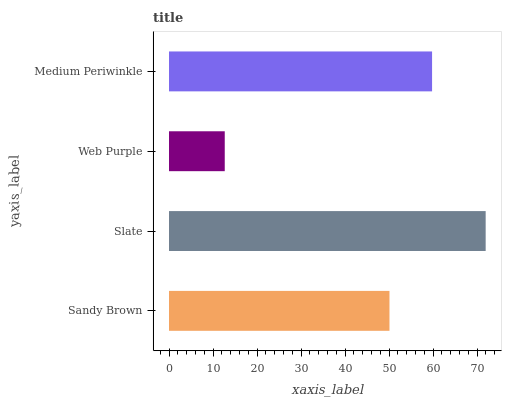Is Web Purple the minimum?
Answer yes or no. Yes. Is Slate the maximum?
Answer yes or no. Yes. Is Slate the minimum?
Answer yes or no. No. Is Web Purple the maximum?
Answer yes or no. No. Is Slate greater than Web Purple?
Answer yes or no. Yes. Is Web Purple less than Slate?
Answer yes or no. Yes. Is Web Purple greater than Slate?
Answer yes or no. No. Is Slate less than Web Purple?
Answer yes or no. No. Is Medium Periwinkle the high median?
Answer yes or no. Yes. Is Sandy Brown the low median?
Answer yes or no. Yes. Is Web Purple the high median?
Answer yes or no. No. Is Medium Periwinkle the low median?
Answer yes or no. No. 